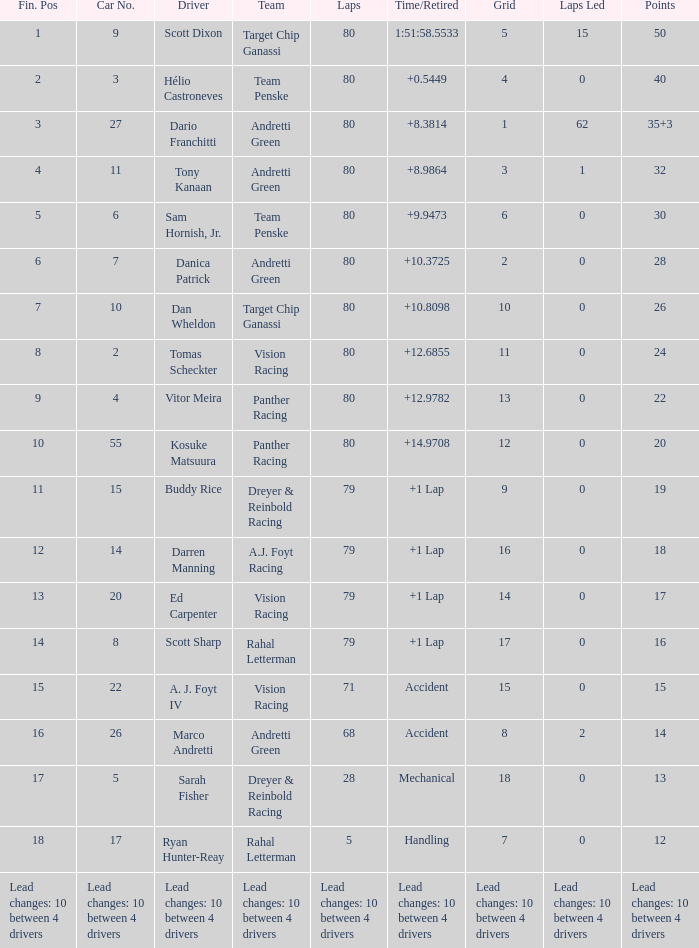How many laps does driver dario franchitti have? 80.0. 